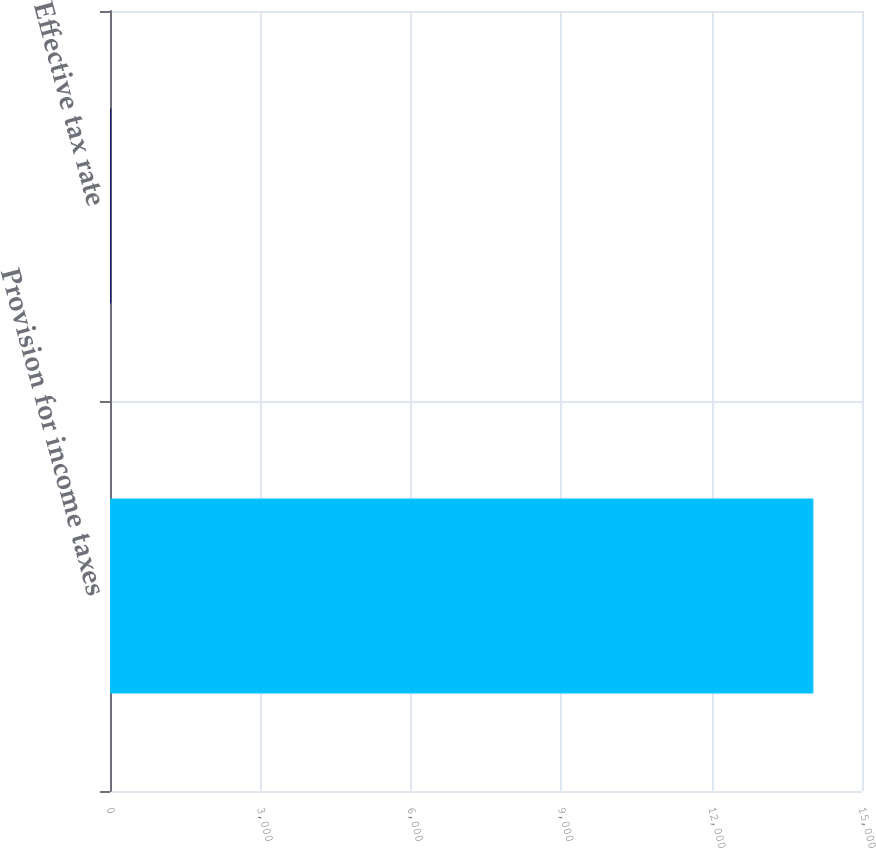<chart> <loc_0><loc_0><loc_500><loc_500><bar_chart><fcel>Provision for income taxes<fcel>Effective tax rate<nl><fcel>14030<fcel>25.2<nl></chart> 